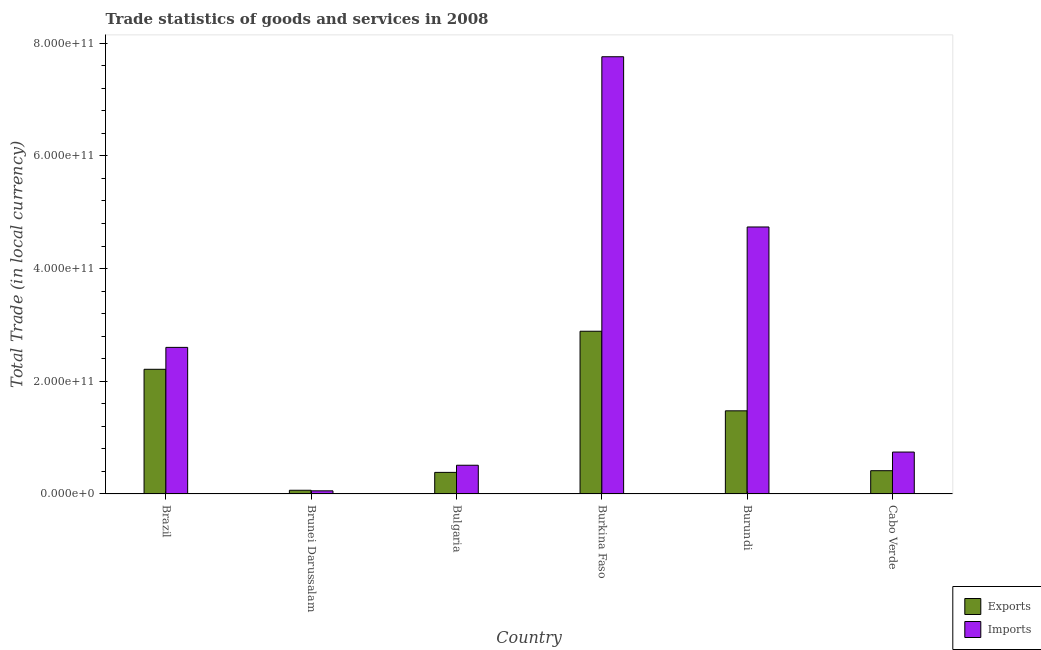Are the number of bars per tick equal to the number of legend labels?
Provide a succinct answer. Yes. What is the label of the 5th group of bars from the left?
Your answer should be compact. Burundi. In how many cases, is the number of bars for a given country not equal to the number of legend labels?
Make the answer very short. 0. What is the imports of goods and services in Bulgaria?
Offer a very short reply. 5.10e+1. Across all countries, what is the maximum imports of goods and services?
Keep it short and to the point. 7.76e+11. Across all countries, what is the minimum export of goods and services?
Ensure brevity in your answer.  6.58e+09. In which country was the imports of goods and services maximum?
Keep it short and to the point. Burkina Faso. In which country was the imports of goods and services minimum?
Your answer should be compact. Brunei Darussalam. What is the total export of goods and services in the graph?
Keep it short and to the point. 7.44e+11. What is the difference between the export of goods and services in Bulgaria and that in Burundi?
Offer a terse response. -1.09e+11. What is the difference between the imports of goods and services in Brunei Darussalam and the export of goods and services in Burundi?
Offer a very short reply. -1.42e+11. What is the average imports of goods and services per country?
Ensure brevity in your answer.  2.73e+11. What is the difference between the export of goods and services and imports of goods and services in Brazil?
Offer a very short reply. -3.89e+1. In how many countries, is the imports of goods and services greater than 80000000000 LCU?
Your answer should be compact. 3. What is the ratio of the imports of goods and services in Brunei Darussalam to that in Cabo Verde?
Make the answer very short. 0.07. Is the difference between the imports of goods and services in Brunei Darussalam and Burkina Faso greater than the difference between the export of goods and services in Brunei Darussalam and Burkina Faso?
Your response must be concise. No. What is the difference between the highest and the second highest imports of goods and services?
Offer a very short reply. 3.02e+11. What is the difference between the highest and the lowest export of goods and services?
Ensure brevity in your answer.  2.82e+11. In how many countries, is the export of goods and services greater than the average export of goods and services taken over all countries?
Provide a short and direct response. 3. Is the sum of the export of goods and services in Brazil and Burundi greater than the maximum imports of goods and services across all countries?
Offer a very short reply. No. What does the 1st bar from the left in Burundi represents?
Your response must be concise. Exports. What does the 2nd bar from the right in Brunei Darussalam represents?
Your answer should be very brief. Exports. How many bars are there?
Offer a very short reply. 12. How many countries are there in the graph?
Your response must be concise. 6. What is the difference between two consecutive major ticks on the Y-axis?
Your answer should be compact. 2.00e+11. Are the values on the major ticks of Y-axis written in scientific E-notation?
Your response must be concise. Yes. Where does the legend appear in the graph?
Provide a short and direct response. Bottom right. How many legend labels are there?
Your response must be concise. 2. What is the title of the graph?
Your answer should be very brief. Trade statistics of goods and services in 2008. What is the label or title of the X-axis?
Make the answer very short. Country. What is the label or title of the Y-axis?
Make the answer very short. Total Trade (in local currency). What is the Total Trade (in local currency) of Exports in Brazil?
Give a very brief answer. 2.21e+11. What is the Total Trade (in local currency) of Imports in Brazil?
Ensure brevity in your answer.  2.60e+11. What is the Total Trade (in local currency) in Exports in Brunei Darussalam?
Offer a terse response. 6.58e+09. What is the Total Trade (in local currency) of Imports in Brunei Darussalam?
Provide a short and direct response. 5.56e+09. What is the Total Trade (in local currency) of Exports in Bulgaria?
Your answer should be very brief. 3.83e+1. What is the Total Trade (in local currency) of Imports in Bulgaria?
Give a very brief answer. 5.10e+1. What is the Total Trade (in local currency) of Exports in Burkina Faso?
Ensure brevity in your answer.  2.89e+11. What is the Total Trade (in local currency) in Imports in Burkina Faso?
Keep it short and to the point. 7.76e+11. What is the Total Trade (in local currency) of Exports in Burundi?
Provide a succinct answer. 1.48e+11. What is the Total Trade (in local currency) of Imports in Burundi?
Make the answer very short. 4.74e+11. What is the Total Trade (in local currency) of Exports in Cabo Verde?
Provide a short and direct response. 4.13e+1. What is the Total Trade (in local currency) in Imports in Cabo Verde?
Offer a terse response. 7.44e+1. Across all countries, what is the maximum Total Trade (in local currency) of Exports?
Your response must be concise. 2.89e+11. Across all countries, what is the maximum Total Trade (in local currency) in Imports?
Offer a terse response. 7.76e+11. Across all countries, what is the minimum Total Trade (in local currency) in Exports?
Offer a very short reply. 6.58e+09. Across all countries, what is the minimum Total Trade (in local currency) in Imports?
Your answer should be compact. 5.56e+09. What is the total Total Trade (in local currency) of Exports in the graph?
Offer a very short reply. 7.44e+11. What is the total Total Trade (in local currency) of Imports in the graph?
Ensure brevity in your answer.  1.64e+12. What is the difference between the Total Trade (in local currency) in Exports in Brazil and that in Brunei Darussalam?
Keep it short and to the point. 2.15e+11. What is the difference between the Total Trade (in local currency) of Imports in Brazil and that in Brunei Darussalam?
Offer a terse response. 2.55e+11. What is the difference between the Total Trade (in local currency) of Exports in Brazil and that in Bulgaria?
Provide a succinct answer. 1.83e+11. What is the difference between the Total Trade (in local currency) of Imports in Brazil and that in Bulgaria?
Your response must be concise. 2.09e+11. What is the difference between the Total Trade (in local currency) of Exports in Brazil and that in Burkina Faso?
Your response must be concise. -6.75e+1. What is the difference between the Total Trade (in local currency) of Imports in Brazil and that in Burkina Faso?
Provide a succinct answer. -5.16e+11. What is the difference between the Total Trade (in local currency) in Exports in Brazil and that in Burundi?
Ensure brevity in your answer.  7.37e+1. What is the difference between the Total Trade (in local currency) of Imports in Brazil and that in Burundi?
Your response must be concise. -2.14e+11. What is the difference between the Total Trade (in local currency) of Exports in Brazil and that in Cabo Verde?
Your answer should be compact. 1.80e+11. What is the difference between the Total Trade (in local currency) in Imports in Brazil and that in Cabo Verde?
Keep it short and to the point. 1.86e+11. What is the difference between the Total Trade (in local currency) of Exports in Brunei Darussalam and that in Bulgaria?
Offer a terse response. -3.17e+1. What is the difference between the Total Trade (in local currency) in Imports in Brunei Darussalam and that in Bulgaria?
Provide a short and direct response. -4.54e+1. What is the difference between the Total Trade (in local currency) in Exports in Brunei Darussalam and that in Burkina Faso?
Provide a short and direct response. -2.82e+11. What is the difference between the Total Trade (in local currency) of Imports in Brunei Darussalam and that in Burkina Faso?
Make the answer very short. -7.70e+11. What is the difference between the Total Trade (in local currency) of Exports in Brunei Darussalam and that in Burundi?
Your response must be concise. -1.41e+11. What is the difference between the Total Trade (in local currency) of Imports in Brunei Darussalam and that in Burundi?
Give a very brief answer. -4.68e+11. What is the difference between the Total Trade (in local currency) in Exports in Brunei Darussalam and that in Cabo Verde?
Provide a short and direct response. -3.47e+1. What is the difference between the Total Trade (in local currency) in Imports in Brunei Darussalam and that in Cabo Verde?
Your response must be concise. -6.88e+1. What is the difference between the Total Trade (in local currency) in Exports in Bulgaria and that in Burkina Faso?
Provide a short and direct response. -2.50e+11. What is the difference between the Total Trade (in local currency) of Imports in Bulgaria and that in Burkina Faso?
Make the answer very short. -7.25e+11. What is the difference between the Total Trade (in local currency) in Exports in Bulgaria and that in Burundi?
Keep it short and to the point. -1.09e+11. What is the difference between the Total Trade (in local currency) of Imports in Bulgaria and that in Burundi?
Offer a terse response. -4.23e+11. What is the difference between the Total Trade (in local currency) of Exports in Bulgaria and that in Cabo Verde?
Keep it short and to the point. -2.98e+09. What is the difference between the Total Trade (in local currency) of Imports in Bulgaria and that in Cabo Verde?
Your answer should be compact. -2.34e+1. What is the difference between the Total Trade (in local currency) in Exports in Burkina Faso and that in Burundi?
Provide a short and direct response. 1.41e+11. What is the difference between the Total Trade (in local currency) in Imports in Burkina Faso and that in Burundi?
Make the answer very short. 3.02e+11. What is the difference between the Total Trade (in local currency) in Exports in Burkina Faso and that in Cabo Verde?
Ensure brevity in your answer.  2.47e+11. What is the difference between the Total Trade (in local currency) of Imports in Burkina Faso and that in Cabo Verde?
Ensure brevity in your answer.  7.02e+11. What is the difference between the Total Trade (in local currency) of Exports in Burundi and that in Cabo Verde?
Keep it short and to the point. 1.06e+11. What is the difference between the Total Trade (in local currency) in Imports in Burundi and that in Cabo Verde?
Provide a short and direct response. 3.99e+11. What is the difference between the Total Trade (in local currency) in Exports in Brazil and the Total Trade (in local currency) in Imports in Brunei Darussalam?
Provide a short and direct response. 2.16e+11. What is the difference between the Total Trade (in local currency) of Exports in Brazil and the Total Trade (in local currency) of Imports in Bulgaria?
Keep it short and to the point. 1.70e+11. What is the difference between the Total Trade (in local currency) of Exports in Brazil and the Total Trade (in local currency) of Imports in Burkina Faso?
Offer a very short reply. -5.55e+11. What is the difference between the Total Trade (in local currency) of Exports in Brazil and the Total Trade (in local currency) of Imports in Burundi?
Ensure brevity in your answer.  -2.53e+11. What is the difference between the Total Trade (in local currency) of Exports in Brazil and the Total Trade (in local currency) of Imports in Cabo Verde?
Provide a short and direct response. 1.47e+11. What is the difference between the Total Trade (in local currency) in Exports in Brunei Darussalam and the Total Trade (in local currency) in Imports in Bulgaria?
Provide a short and direct response. -4.44e+1. What is the difference between the Total Trade (in local currency) in Exports in Brunei Darussalam and the Total Trade (in local currency) in Imports in Burkina Faso?
Give a very brief answer. -7.69e+11. What is the difference between the Total Trade (in local currency) in Exports in Brunei Darussalam and the Total Trade (in local currency) in Imports in Burundi?
Provide a succinct answer. -4.67e+11. What is the difference between the Total Trade (in local currency) of Exports in Brunei Darussalam and the Total Trade (in local currency) of Imports in Cabo Verde?
Your answer should be very brief. -6.78e+1. What is the difference between the Total Trade (in local currency) of Exports in Bulgaria and the Total Trade (in local currency) of Imports in Burkina Faso?
Your answer should be compact. -7.38e+11. What is the difference between the Total Trade (in local currency) in Exports in Bulgaria and the Total Trade (in local currency) in Imports in Burundi?
Your response must be concise. -4.36e+11. What is the difference between the Total Trade (in local currency) in Exports in Bulgaria and the Total Trade (in local currency) in Imports in Cabo Verde?
Offer a terse response. -3.61e+1. What is the difference between the Total Trade (in local currency) in Exports in Burkina Faso and the Total Trade (in local currency) in Imports in Burundi?
Your response must be concise. -1.85e+11. What is the difference between the Total Trade (in local currency) in Exports in Burkina Faso and the Total Trade (in local currency) in Imports in Cabo Verde?
Provide a succinct answer. 2.14e+11. What is the difference between the Total Trade (in local currency) of Exports in Burundi and the Total Trade (in local currency) of Imports in Cabo Verde?
Offer a very short reply. 7.32e+1. What is the average Total Trade (in local currency) of Exports per country?
Give a very brief answer. 1.24e+11. What is the average Total Trade (in local currency) in Imports per country?
Give a very brief answer. 2.73e+11. What is the difference between the Total Trade (in local currency) of Exports and Total Trade (in local currency) of Imports in Brazil?
Provide a short and direct response. -3.89e+1. What is the difference between the Total Trade (in local currency) in Exports and Total Trade (in local currency) in Imports in Brunei Darussalam?
Provide a short and direct response. 1.02e+09. What is the difference between the Total Trade (in local currency) of Exports and Total Trade (in local currency) of Imports in Bulgaria?
Ensure brevity in your answer.  -1.27e+1. What is the difference between the Total Trade (in local currency) of Exports and Total Trade (in local currency) of Imports in Burkina Faso?
Your response must be concise. -4.87e+11. What is the difference between the Total Trade (in local currency) of Exports and Total Trade (in local currency) of Imports in Burundi?
Your answer should be very brief. -3.26e+11. What is the difference between the Total Trade (in local currency) in Exports and Total Trade (in local currency) in Imports in Cabo Verde?
Provide a short and direct response. -3.31e+1. What is the ratio of the Total Trade (in local currency) of Exports in Brazil to that in Brunei Darussalam?
Provide a succinct answer. 33.65. What is the ratio of the Total Trade (in local currency) in Imports in Brazil to that in Brunei Darussalam?
Make the answer very short. 46.79. What is the ratio of the Total Trade (in local currency) of Exports in Brazil to that in Bulgaria?
Your answer should be very brief. 5.77. What is the ratio of the Total Trade (in local currency) in Imports in Brazil to that in Bulgaria?
Keep it short and to the point. 5.1. What is the ratio of the Total Trade (in local currency) of Exports in Brazil to that in Burkina Faso?
Your answer should be compact. 0.77. What is the ratio of the Total Trade (in local currency) in Imports in Brazil to that in Burkina Faso?
Your response must be concise. 0.34. What is the ratio of the Total Trade (in local currency) of Exports in Brazil to that in Burundi?
Keep it short and to the point. 1.5. What is the ratio of the Total Trade (in local currency) in Imports in Brazil to that in Burundi?
Ensure brevity in your answer.  0.55. What is the ratio of the Total Trade (in local currency) of Exports in Brazil to that in Cabo Verde?
Ensure brevity in your answer.  5.36. What is the ratio of the Total Trade (in local currency) in Imports in Brazil to that in Cabo Verde?
Offer a terse response. 3.5. What is the ratio of the Total Trade (in local currency) in Exports in Brunei Darussalam to that in Bulgaria?
Your response must be concise. 0.17. What is the ratio of the Total Trade (in local currency) of Imports in Brunei Darussalam to that in Bulgaria?
Give a very brief answer. 0.11. What is the ratio of the Total Trade (in local currency) of Exports in Brunei Darussalam to that in Burkina Faso?
Make the answer very short. 0.02. What is the ratio of the Total Trade (in local currency) of Imports in Brunei Darussalam to that in Burkina Faso?
Your response must be concise. 0.01. What is the ratio of the Total Trade (in local currency) in Exports in Brunei Darussalam to that in Burundi?
Your answer should be compact. 0.04. What is the ratio of the Total Trade (in local currency) of Imports in Brunei Darussalam to that in Burundi?
Your answer should be compact. 0.01. What is the ratio of the Total Trade (in local currency) in Exports in Brunei Darussalam to that in Cabo Verde?
Your answer should be compact. 0.16. What is the ratio of the Total Trade (in local currency) of Imports in Brunei Darussalam to that in Cabo Verde?
Offer a terse response. 0.07. What is the ratio of the Total Trade (in local currency) in Exports in Bulgaria to that in Burkina Faso?
Offer a very short reply. 0.13. What is the ratio of the Total Trade (in local currency) in Imports in Bulgaria to that in Burkina Faso?
Provide a succinct answer. 0.07. What is the ratio of the Total Trade (in local currency) in Exports in Bulgaria to that in Burundi?
Provide a succinct answer. 0.26. What is the ratio of the Total Trade (in local currency) of Imports in Bulgaria to that in Burundi?
Your answer should be very brief. 0.11. What is the ratio of the Total Trade (in local currency) of Exports in Bulgaria to that in Cabo Verde?
Offer a terse response. 0.93. What is the ratio of the Total Trade (in local currency) in Imports in Bulgaria to that in Cabo Verde?
Provide a succinct answer. 0.69. What is the ratio of the Total Trade (in local currency) in Exports in Burkina Faso to that in Burundi?
Make the answer very short. 1.96. What is the ratio of the Total Trade (in local currency) in Imports in Burkina Faso to that in Burundi?
Make the answer very short. 1.64. What is the ratio of the Total Trade (in local currency) of Exports in Burkina Faso to that in Cabo Verde?
Your answer should be compact. 6.99. What is the ratio of the Total Trade (in local currency) in Imports in Burkina Faso to that in Cabo Verde?
Your answer should be very brief. 10.43. What is the ratio of the Total Trade (in local currency) of Exports in Burundi to that in Cabo Verde?
Offer a terse response. 3.57. What is the ratio of the Total Trade (in local currency) of Imports in Burundi to that in Cabo Verde?
Offer a terse response. 6.37. What is the difference between the highest and the second highest Total Trade (in local currency) in Exports?
Your answer should be compact. 6.75e+1. What is the difference between the highest and the second highest Total Trade (in local currency) in Imports?
Give a very brief answer. 3.02e+11. What is the difference between the highest and the lowest Total Trade (in local currency) in Exports?
Ensure brevity in your answer.  2.82e+11. What is the difference between the highest and the lowest Total Trade (in local currency) in Imports?
Ensure brevity in your answer.  7.70e+11. 